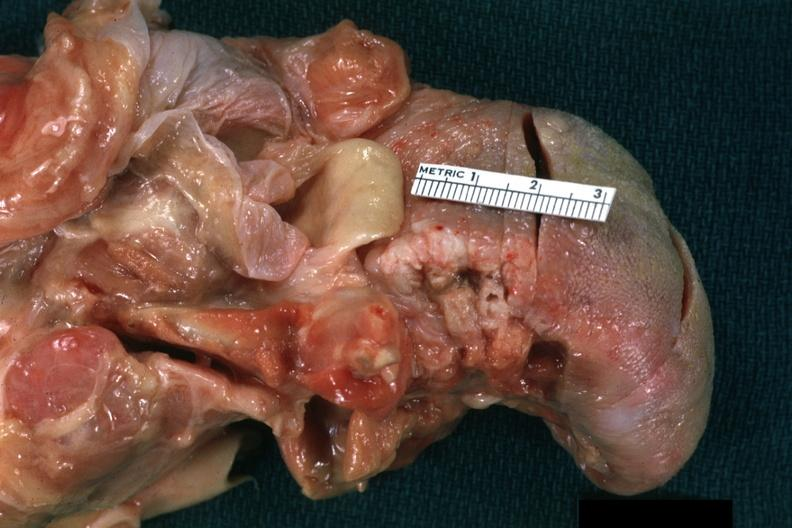where is this?
Answer the question using a single word or phrase. Oral 